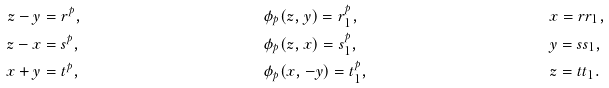Convert formula to latex. <formula><loc_0><loc_0><loc_500><loc_500>z - y & = r ^ { p } , & & \phi _ { p } ( z , y ) = r _ { 1 } ^ { p } , & & x = r r _ { 1 } , \\ z - x & = s ^ { p } , & & \phi _ { p } ( z , x ) = s _ { 1 } ^ { p } , & & y = s s _ { 1 } , \\ x + y & = t ^ { p } , & & \phi _ { p } ( x , - y ) = t _ { 1 } ^ { p } , & & z = t t _ { 1 } .</formula> 